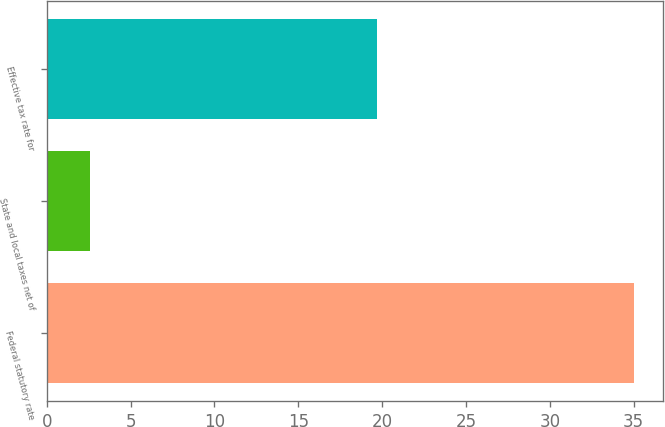Convert chart. <chart><loc_0><loc_0><loc_500><loc_500><bar_chart><fcel>Federal statutory rate<fcel>State and local taxes net of<fcel>Effective tax rate for<nl><fcel>35<fcel>2.6<fcel>19.7<nl></chart> 